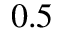Convert formula to latex. <formula><loc_0><loc_0><loc_500><loc_500>0 { . } 5</formula> 